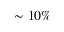Convert formula to latex. <formula><loc_0><loc_0><loc_500><loc_500>\sim 1 0 \%</formula> 